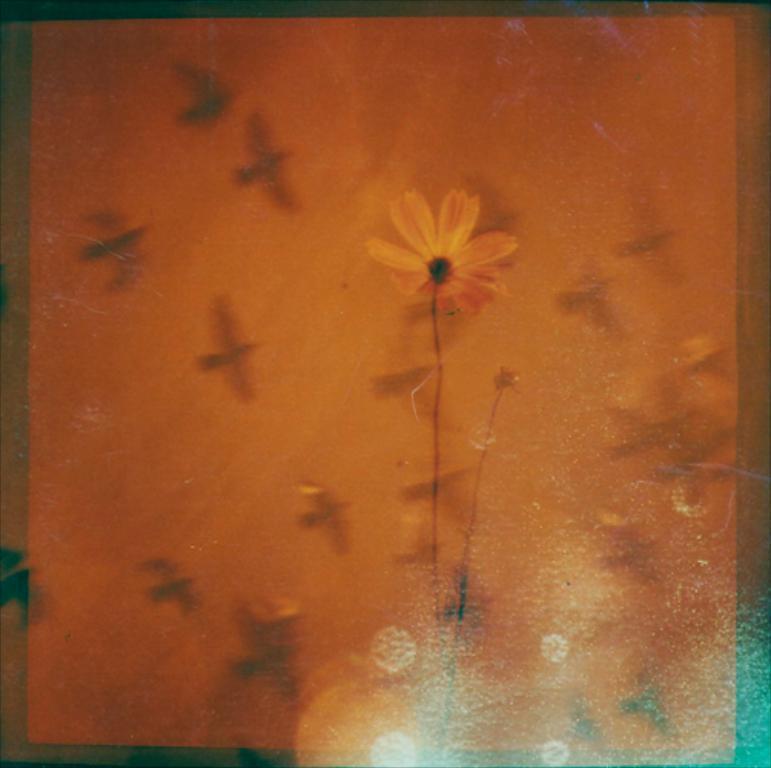Describe this image in one or two sentences. In this image we can see a flower, stems and birds are flying in the air. 